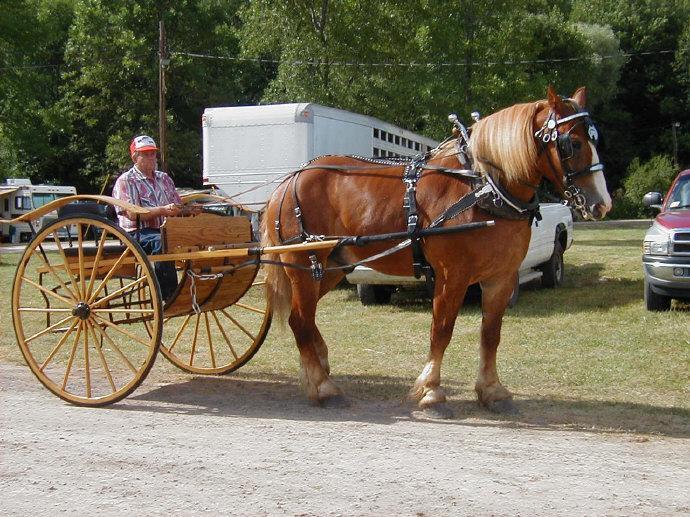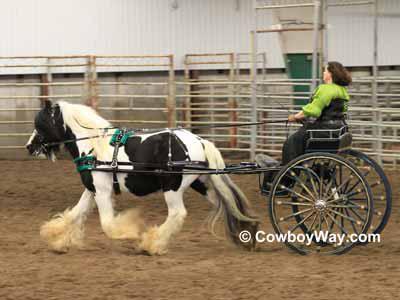The first image is the image on the left, the second image is the image on the right. For the images displayed, is the sentence "Both of the carts are covered." factually correct? Answer yes or no. No. 